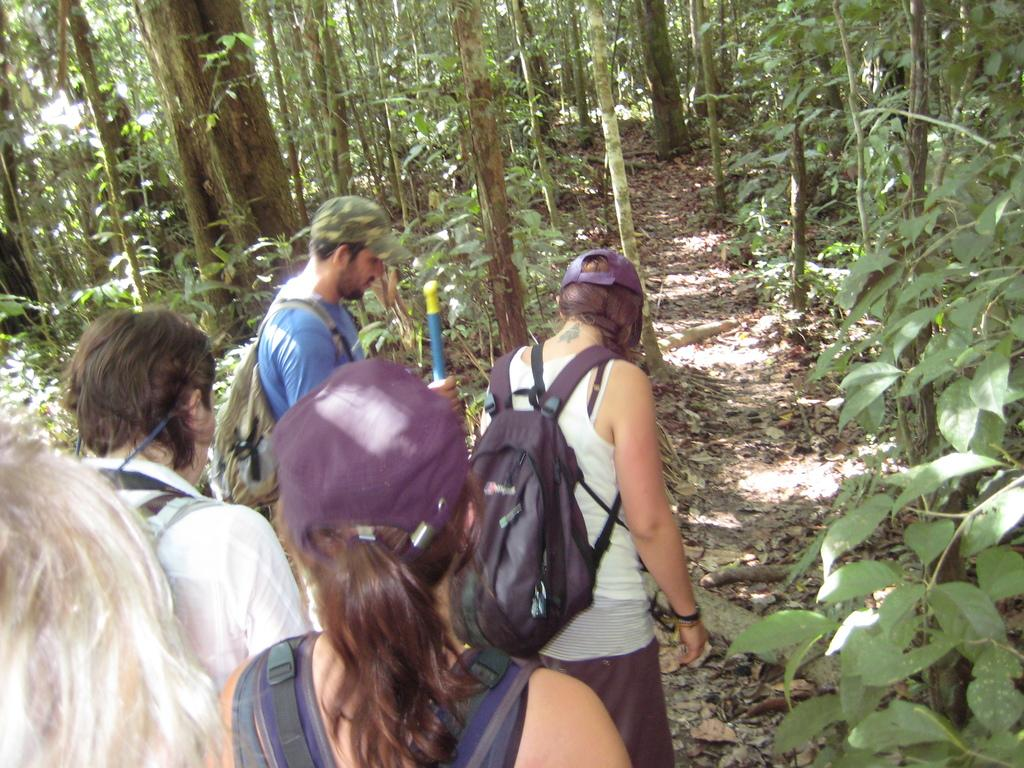What type of environment is shown in the image? The image depicts a forest. What can be seen in the forest? There are trees in the image. Are there any people in the image? Yes, there are persons standing in the image. What are two of the persons wearing? Two of the persons are wearing bags and two of the persons are wearing caps. What is the current view of the women in the image? There is no mention of women in the image; it features persons, but their gender is not specified. 